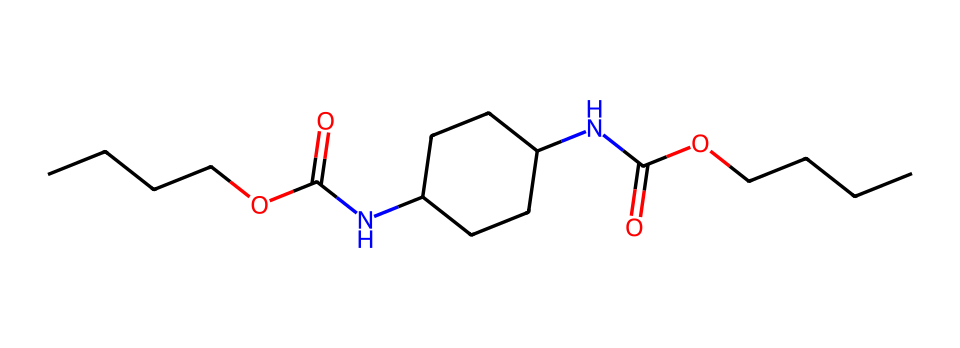What is the total number of carbon atoms in this compound? By examining the SMILES representation, which contains segments beginning with 'C' and the count of 'C' in the full structure, we find there are 15 carbon atoms present.
Answer: 15 How many nitrogen atoms are present in this chemical? The SMILES shows 'N' appearing twice, indicating there are two nitrogen atoms in the structure.
Answer: 2 What type of functional group is represented by 'C(=O)'? This indicates a carbonyl functional group due to the presence of a carbon atom double-bonded to an oxygen atom, characteristic of carboxylic acids or amides.
Answer: carbonyl Which functional group contributes to the polar nature of this compound? The presence of the amide groups 'NC(=O)' and the carboxylic acid part 'C(=O)O' makes the compound polar due to the electronegative nitrogen and oxygen atoms.
Answer: amide and carboxylic acid How many ester linkages can be identified in this structure? The presence of the 'OC(=O)' structure highlights that there are two ester linkages within the chemical structure.
Answer: 2 What is the significance of including fullerides in swimwear coatings? Fullerides enhance the hydrophobic properties and potentially enhance performance by reducing drag in competitive swimming applications due to their unique structures.
Answer: hydrophobic properties What unique feature of fullerides improves the durability and resilience of the swimwear? Fullerides possess a robust cage-like structure that provides high resistance to wear and tear, contributing to the swimwear's durability.
Answer: robust cage-like structure 